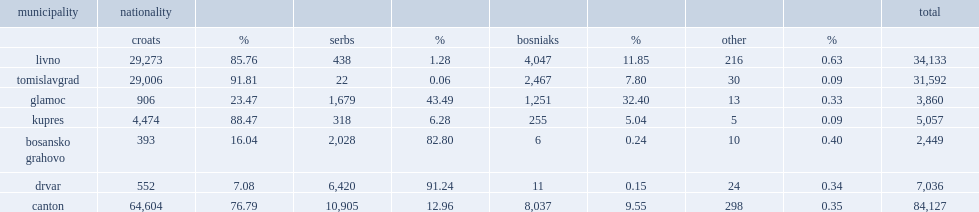What was the population percentage of croats? 76.79. 